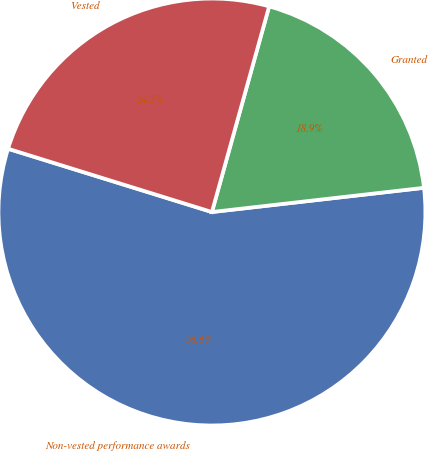Convert chart. <chart><loc_0><loc_0><loc_500><loc_500><pie_chart><fcel>Non-vested performance awards<fcel>Granted<fcel>Vested<nl><fcel>56.6%<fcel>18.87%<fcel>24.53%<nl></chart> 